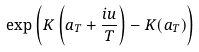<formula> <loc_0><loc_0><loc_500><loc_500>\exp \left ( K \left ( a _ { T } + \frac { i u } { T } \right ) - K ( a _ { T } ) \right )</formula> 